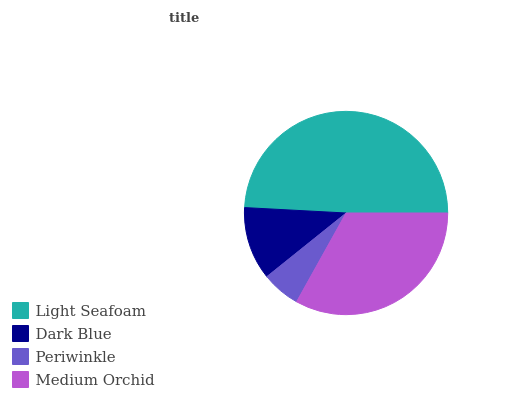Is Periwinkle the minimum?
Answer yes or no. Yes. Is Light Seafoam the maximum?
Answer yes or no. Yes. Is Dark Blue the minimum?
Answer yes or no. No. Is Dark Blue the maximum?
Answer yes or no. No. Is Light Seafoam greater than Dark Blue?
Answer yes or no. Yes. Is Dark Blue less than Light Seafoam?
Answer yes or no. Yes. Is Dark Blue greater than Light Seafoam?
Answer yes or no. No. Is Light Seafoam less than Dark Blue?
Answer yes or no. No. Is Medium Orchid the high median?
Answer yes or no. Yes. Is Dark Blue the low median?
Answer yes or no. Yes. Is Light Seafoam the high median?
Answer yes or no. No. Is Light Seafoam the low median?
Answer yes or no. No. 